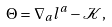Convert formula to latex. <formula><loc_0><loc_0><loc_500><loc_500>\Theta = \nabla _ { a } l ^ { a } - \mathcal { K } ,</formula> 